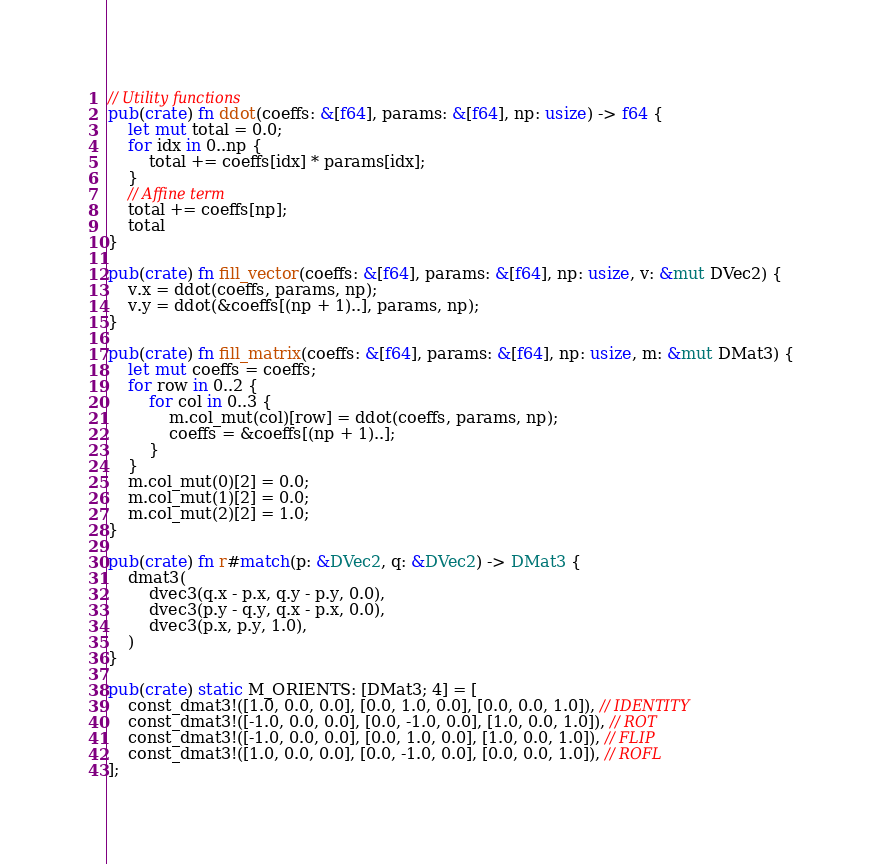Convert code to text. <code><loc_0><loc_0><loc_500><loc_500><_Rust_>// Utility functions
pub(crate) fn ddot(coeffs: &[f64], params: &[f64], np: usize) -> f64 {
    let mut total = 0.0;
    for idx in 0..np {
        total += coeffs[idx] * params[idx];
    }
    // Affine term
    total += coeffs[np];
    total
}

pub(crate) fn fill_vector(coeffs: &[f64], params: &[f64], np: usize, v: &mut DVec2) {
    v.x = ddot(coeffs, params, np);
    v.y = ddot(&coeffs[(np + 1)..], params, np);
}

pub(crate) fn fill_matrix(coeffs: &[f64], params: &[f64], np: usize, m: &mut DMat3) {
    let mut coeffs = coeffs;
    for row in 0..2 {
        for col in 0..3 {
            m.col_mut(col)[row] = ddot(coeffs, params, np);
            coeffs = &coeffs[(np + 1)..];
        }
    }
    m.col_mut(0)[2] = 0.0;
    m.col_mut(1)[2] = 0.0;
    m.col_mut(2)[2] = 1.0;
}

pub(crate) fn r#match(p: &DVec2, q: &DVec2) -> DMat3 {
    dmat3(
        dvec3(q.x - p.x, q.y - p.y, 0.0),
        dvec3(p.y - q.y, q.x - p.x, 0.0),
        dvec3(p.x, p.y, 1.0),
    )
}

pub(crate) static M_ORIENTS: [DMat3; 4] = [
    const_dmat3!([1.0, 0.0, 0.0], [0.0, 1.0, 0.0], [0.0, 0.0, 1.0]), // IDENTITY
    const_dmat3!([-1.0, 0.0, 0.0], [0.0, -1.0, 0.0], [1.0, 0.0, 1.0]), // ROT
    const_dmat3!([-1.0, 0.0, 0.0], [0.0, 1.0, 0.0], [1.0, 0.0, 1.0]), // FLIP
    const_dmat3!([1.0, 0.0, 0.0], [0.0, -1.0, 0.0], [0.0, 0.0, 1.0]), // ROFL
];
</code> 